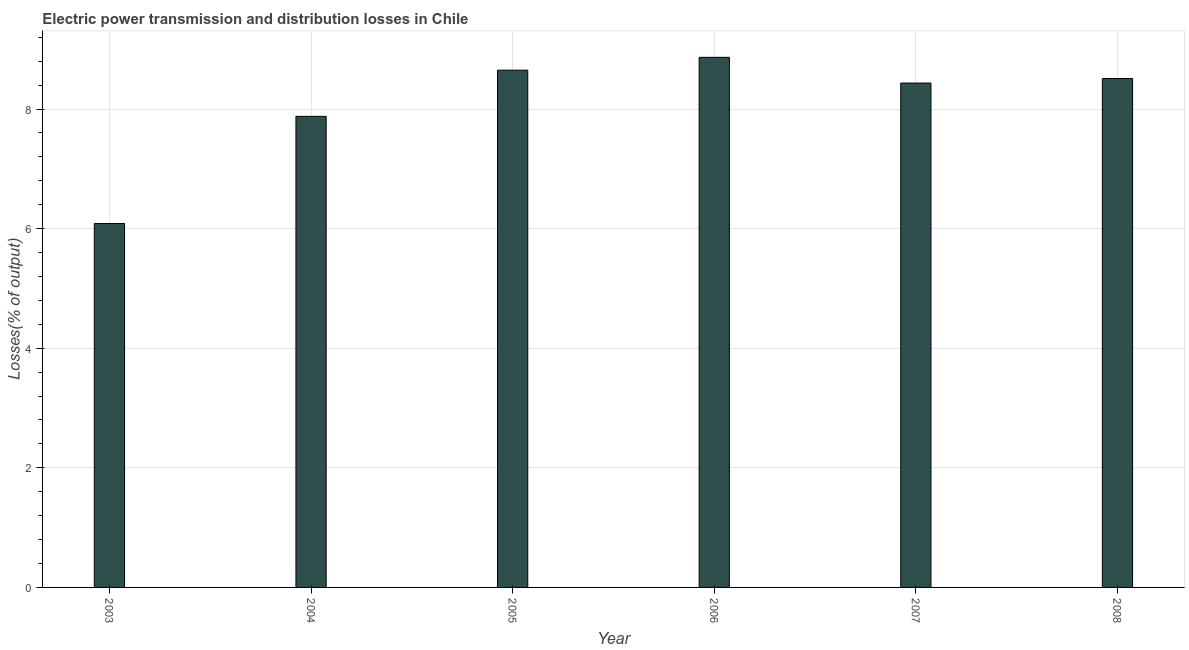Does the graph contain grids?
Make the answer very short. Yes. What is the title of the graph?
Make the answer very short. Electric power transmission and distribution losses in Chile. What is the label or title of the X-axis?
Give a very brief answer. Year. What is the label or title of the Y-axis?
Give a very brief answer. Losses(% of output). What is the electric power transmission and distribution losses in 2007?
Ensure brevity in your answer.  8.43. Across all years, what is the maximum electric power transmission and distribution losses?
Offer a terse response. 8.86. Across all years, what is the minimum electric power transmission and distribution losses?
Provide a succinct answer. 6.09. What is the sum of the electric power transmission and distribution losses?
Provide a short and direct response. 48.42. What is the difference between the electric power transmission and distribution losses in 2003 and 2008?
Provide a short and direct response. -2.42. What is the average electric power transmission and distribution losses per year?
Your response must be concise. 8.07. What is the median electric power transmission and distribution losses?
Give a very brief answer. 8.47. What is the ratio of the electric power transmission and distribution losses in 2007 to that in 2008?
Your answer should be compact. 0.99. Is the electric power transmission and distribution losses in 2003 less than that in 2007?
Offer a terse response. Yes. Is the difference between the electric power transmission and distribution losses in 2006 and 2007 greater than the difference between any two years?
Your answer should be very brief. No. What is the difference between the highest and the second highest electric power transmission and distribution losses?
Keep it short and to the point. 0.21. Is the sum of the electric power transmission and distribution losses in 2005 and 2007 greater than the maximum electric power transmission and distribution losses across all years?
Ensure brevity in your answer.  Yes. What is the difference between the highest and the lowest electric power transmission and distribution losses?
Give a very brief answer. 2.78. In how many years, is the electric power transmission and distribution losses greater than the average electric power transmission and distribution losses taken over all years?
Keep it short and to the point. 4. How many bars are there?
Offer a terse response. 6. What is the Losses(% of output) of 2003?
Provide a succinct answer. 6.09. What is the Losses(% of output) of 2004?
Make the answer very short. 7.88. What is the Losses(% of output) in 2005?
Offer a terse response. 8.65. What is the Losses(% of output) in 2006?
Your answer should be very brief. 8.86. What is the Losses(% of output) of 2007?
Keep it short and to the point. 8.43. What is the Losses(% of output) in 2008?
Make the answer very short. 8.51. What is the difference between the Losses(% of output) in 2003 and 2004?
Provide a short and direct response. -1.79. What is the difference between the Losses(% of output) in 2003 and 2005?
Provide a succinct answer. -2.56. What is the difference between the Losses(% of output) in 2003 and 2006?
Offer a terse response. -2.78. What is the difference between the Losses(% of output) in 2003 and 2007?
Provide a succinct answer. -2.35. What is the difference between the Losses(% of output) in 2003 and 2008?
Ensure brevity in your answer.  -2.42. What is the difference between the Losses(% of output) in 2004 and 2005?
Ensure brevity in your answer.  -0.77. What is the difference between the Losses(% of output) in 2004 and 2006?
Ensure brevity in your answer.  -0.99. What is the difference between the Losses(% of output) in 2004 and 2007?
Ensure brevity in your answer.  -0.56. What is the difference between the Losses(% of output) in 2004 and 2008?
Your answer should be very brief. -0.63. What is the difference between the Losses(% of output) in 2005 and 2006?
Keep it short and to the point. -0.21. What is the difference between the Losses(% of output) in 2005 and 2007?
Ensure brevity in your answer.  0.22. What is the difference between the Losses(% of output) in 2005 and 2008?
Offer a very short reply. 0.14. What is the difference between the Losses(% of output) in 2006 and 2007?
Provide a short and direct response. 0.43. What is the difference between the Losses(% of output) in 2006 and 2008?
Keep it short and to the point. 0.35. What is the difference between the Losses(% of output) in 2007 and 2008?
Provide a short and direct response. -0.08. What is the ratio of the Losses(% of output) in 2003 to that in 2004?
Provide a succinct answer. 0.77. What is the ratio of the Losses(% of output) in 2003 to that in 2005?
Ensure brevity in your answer.  0.7. What is the ratio of the Losses(% of output) in 2003 to that in 2006?
Provide a short and direct response. 0.69. What is the ratio of the Losses(% of output) in 2003 to that in 2007?
Offer a terse response. 0.72. What is the ratio of the Losses(% of output) in 2003 to that in 2008?
Provide a short and direct response. 0.71. What is the ratio of the Losses(% of output) in 2004 to that in 2005?
Make the answer very short. 0.91. What is the ratio of the Losses(% of output) in 2004 to that in 2006?
Offer a terse response. 0.89. What is the ratio of the Losses(% of output) in 2004 to that in 2007?
Provide a short and direct response. 0.93. What is the ratio of the Losses(% of output) in 2004 to that in 2008?
Your answer should be compact. 0.93. What is the ratio of the Losses(% of output) in 2005 to that in 2006?
Offer a terse response. 0.98. What is the ratio of the Losses(% of output) in 2006 to that in 2007?
Your answer should be compact. 1.05. What is the ratio of the Losses(% of output) in 2006 to that in 2008?
Provide a succinct answer. 1.04. 